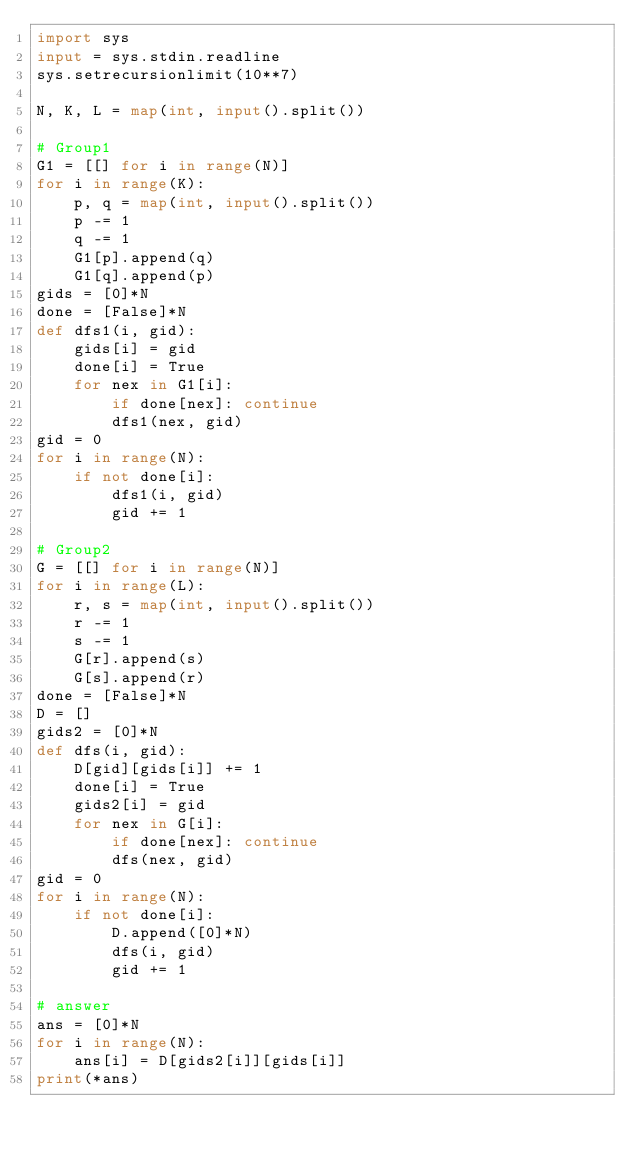Convert code to text. <code><loc_0><loc_0><loc_500><loc_500><_Python_>import sys
input = sys.stdin.readline
sys.setrecursionlimit(10**7)

N, K, L = map(int, input().split())

# Group1
G1 = [[] for i in range(N)]
for i in range(K):
    p, q = map(int, input().split())
    p -= 1
    q -= 1
    G1[p].append(q)
    G1[q].append(p)
gids = [0]*N
done = [False]*N
def dfs1(i, gid):
    gids[i] = gid
    done[i] = True
    for nex in G1[i]:
        if done[nex]: continue
        dfs1(nex, gid)
gid = 0
for i in range(N):
    if not done[i]:
        dfs1(i, gid)
        gid += 1

# Group2
G = [[] for i in range(N)]
for i in range(L):
    r, s = map(int, input().split())
    r -= 1
    s -= 1
    G[r].append(s)
    G[s].append(r)
done = [False]*N
D = []
gids2 = [0]*N
def dfs(i, gid):
    D[gid][gids[i]] += 1
    done[i] = True
    gids2[i] = gid
    for nex in G[i]:
        if done[nex]: continue
        dfs(nex, gid)
gid = 0
for i in range(N):
    if not done[i]:
        D.append([0]*N)
        dfs(i, gid)
        gid += 1

# answer
ans = [0]*N
for i in range(N):
    ans[i] = D[gids2[i]][gids[i]]
print(*ans)
</code> 